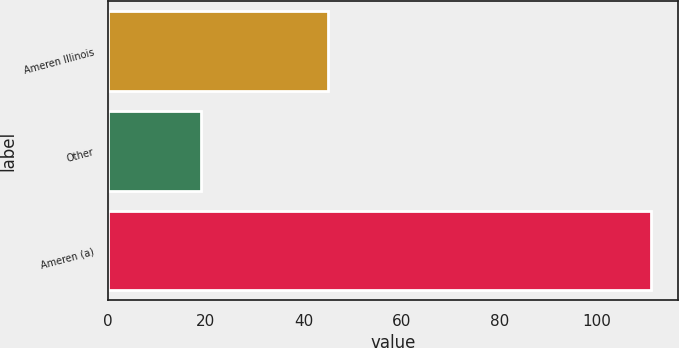Convert chart. <chart><loc_0><loc_0><loc_500><loc_500><bar_chart><fcel>Ameren Illinois<fcel>Other<fcel>Ameren (a)<nl><fcel>45<fcel>19<fcel>111<nl></chart> 